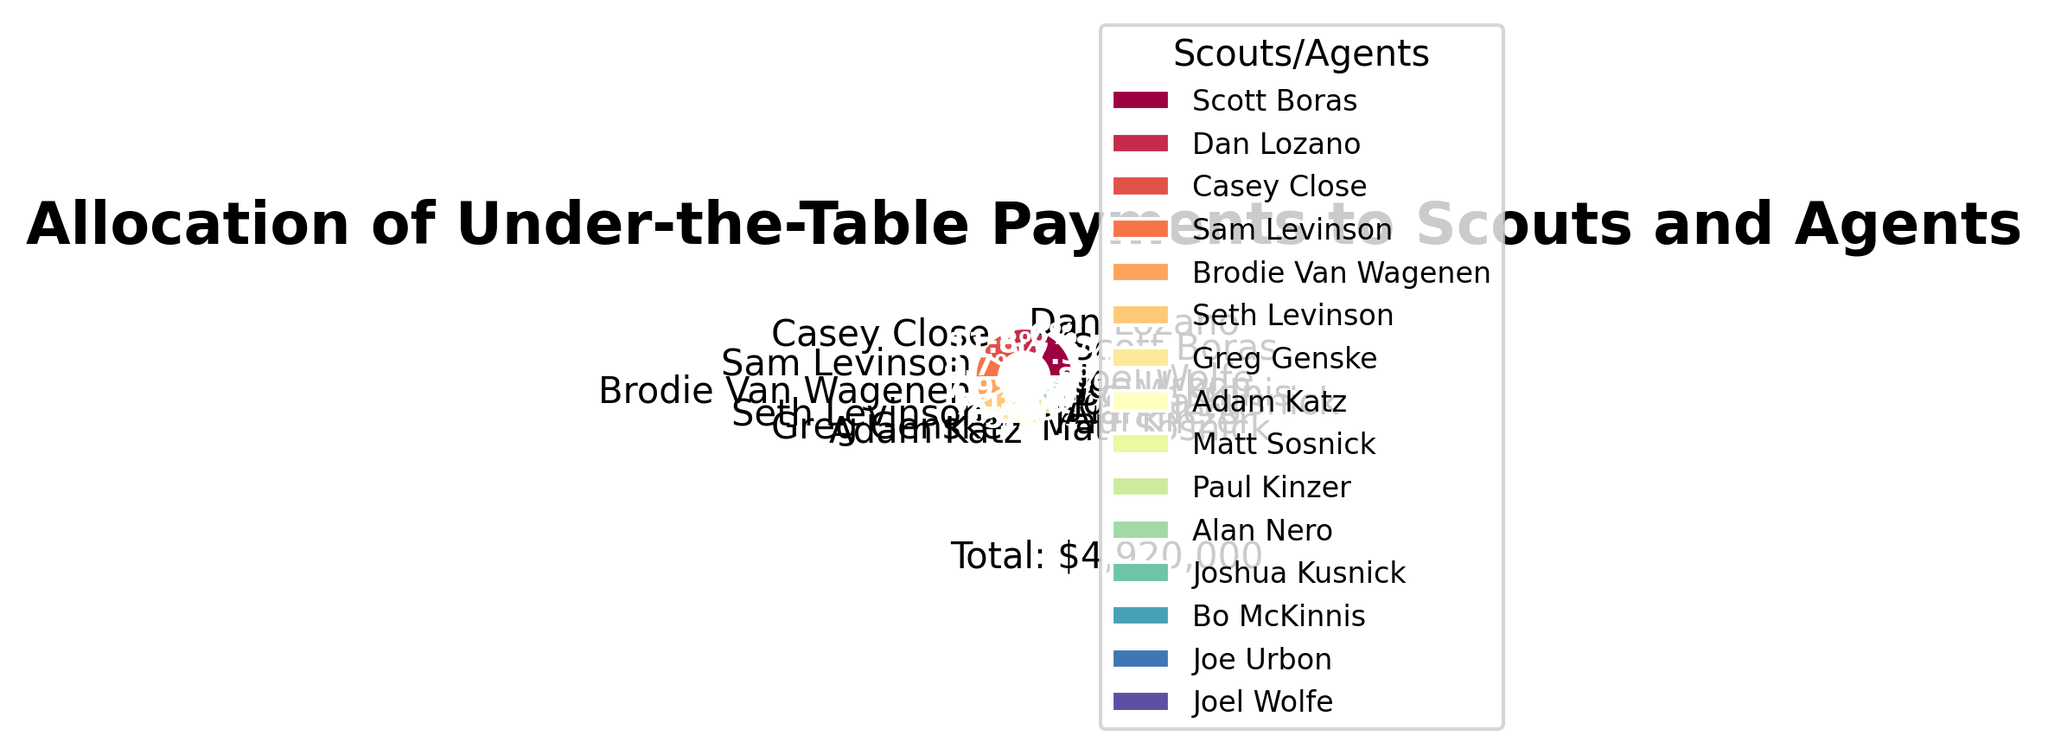Who received the largest allocation of under-the-table payments? The largest slice in the pie chart represents the entity with the highest payment amount. By observing the chart, Scott Boras has the largest slice.
Answer: Scott Boras What's the total amount of under-the-table payments made to both Levinsons (Sam Levinson and Seth Levinson)? Add the payment amounts for Sam Levinson and Seth Levinson. Sam received $430,000 and Seth received $350,000. Summing these amounts gives $430,000 + $350,000 = $780,000.
Answer: $780,000 Between Brodie Van Wagenen and Adam Katz, who received more payments and by how much? From the pie chart, Brodie Van Wagenen received $390,000 and Adam Katz received $280,000. The difference between their payments is $390,000 - $280,000 = $110,000. Brodie received more by $110,000.
Answer: Brodie Van Wagenen, $110,000 What's the percentage allocation of payments given to Joe Urbon? Identify the slice representing Joe Urbon in the pie chart to read its percentage. The chart shows Joe Urbon received 2.0% of the total payments.
Answer: 2.0% Which agent has a payment allocation between 5% and 10%? Review the pie chart sections and their respective percentages. Casey Close received 11.8%, which is higher than 10%, but Dan Lozano, with 12.6%, receipts also fit within the 10% range. Neither fits between exactly 5% and 10%. The remaining agents all received less than 5%. No agent has exactly between 5% and 10% allocation.
Answer: None Which three individuals received the smallest amount of payments? The pie chart's smallest slices correspond to the smallest payment amounts. Observing these, Joe Urbon ($100,000), Joel Wolfe ($90,000), and Bo McKinnis ($120,000) have the smallest slices.
Answer: Joe Urbon, Joel Wolfe, Bo McKinnis How much more did Paul Kinzer receive compared to Matt Sosnick? According to the pie chart, Paul Kinzer received $220,000 and Matt Sosnick received $240,000. The difference is $240,000 - $220,000 = $20,000. Matt Sosnick received more, not Paul.
Answer: $20,000 Who received more payments: Greg Genske or Paul Kinzer? Referring to the pie chart, Greg Genske received $310,000, while Paul Kinzer received $220,000. Consequently, Greg Genske received more.
Answer: Greg Genske What’s the average amount received by the top 5 payment recipients? The top 5 recipients from the pie chart are Scott Boras ($850,000), Dan Lozano ($620,000), Casey Close ($580,000), Sam Levinson ($430,000), and Brodie Van Wagenen ($390,000). Summing these amounts gives $850,000 + $620,000 + $580,000 + $430,000 + $390,000 = $2,870,000. The average is $2,870,000 / 5 = $574,000.
Answer: $574,000 